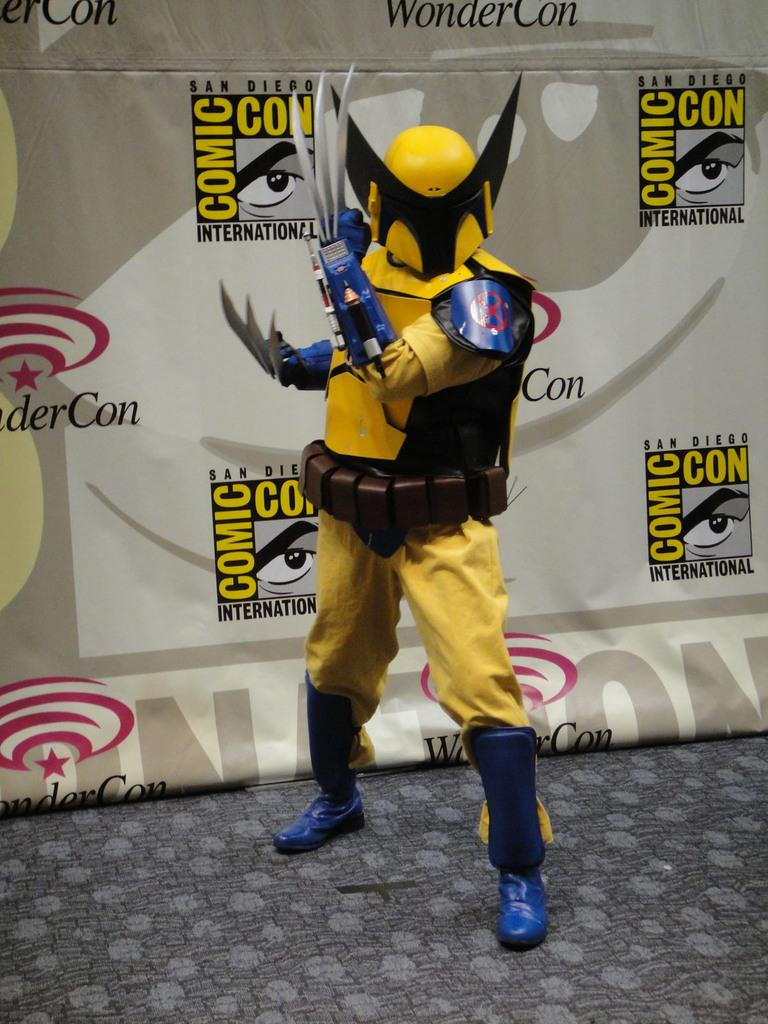What is present in the image? There is a person in the image. Can you describe the person's attire? The person is wearing a fancy dress. What can be seen in the background of the image? There is a banner in the background of the image. What advice does the person in the image give to the person wearing jeans? There is no person wearing jeans in the image, and therefore no advice can be given or received. 